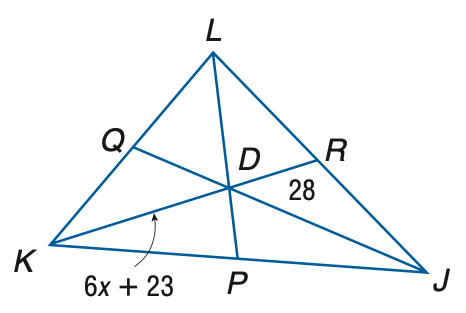Question: Points P, Q, and R are the midpoints of J K, K L, and J L, respectively. Find x.
Choices:
A. 0.83
B. 1.1
C. 2.0
D. 5.5
Answer with the letter. Answer: D 